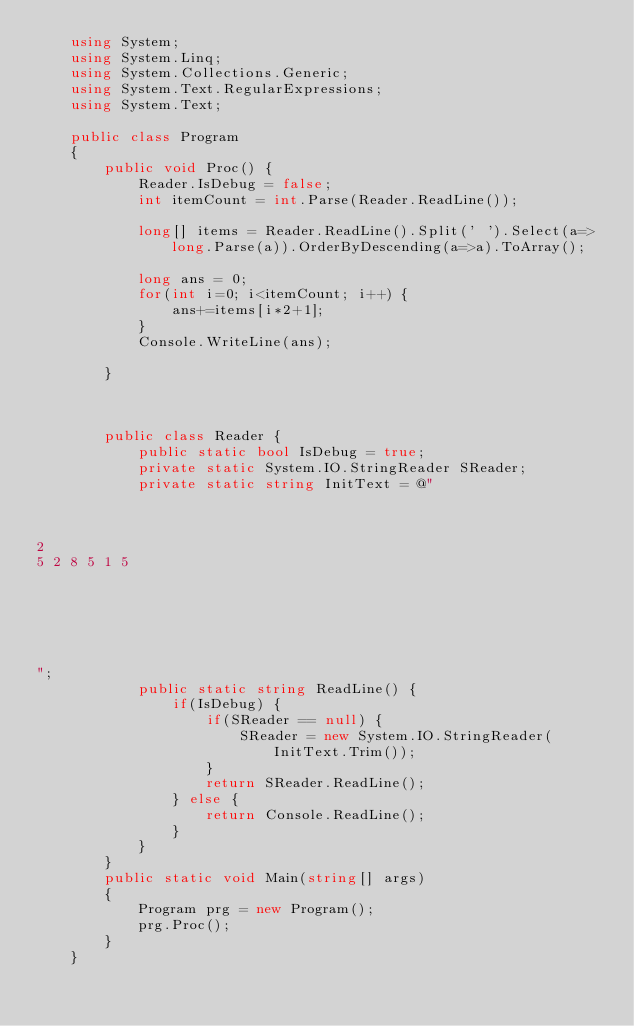<code> <loc_0><loc_0><loc_500><loc_500><_C#_>    using System;
    using System.Linq;
    using System.Collections.Generic;
    using System.Text.RegularExpressions;
    using System.Text;
     
    public class Program
    {
        public void Proc() {
            Reader.IsDebug = false;
            int itemCount = int.Parse(Reader.ReadLine());

            long[] items = Reader.ReadLine().Split(' ').Select(a=>long.Parse(a)).OrderByDescending(a=>a).ToArray();

            long ans = 0;
            for(int i=0; i<itemCount; i++) {
                ans+=items[i*2+1];
            }
            Console.WriteLine(ans);

        }



        public class Reader {
            public static bool IsDebug = true;
            private static System.IO.StringReader SReader;
            private static string InitText = @"



2
5 2 8 5 1 5






";
            public static string ReadLine() {
                if(IsDebug) {
                    if(SReader == null) {
                        SReader = new System.IO.StringReader(InitText.Trim());
                    }
                    return SReader.ReadLine();
                } else {
                    return Console.ReadLine();
                }
            }
        }
        public static void Main(string[] args)
        {
            Program prg = new Program();
            prg.Proc();
        }
    }</code> 